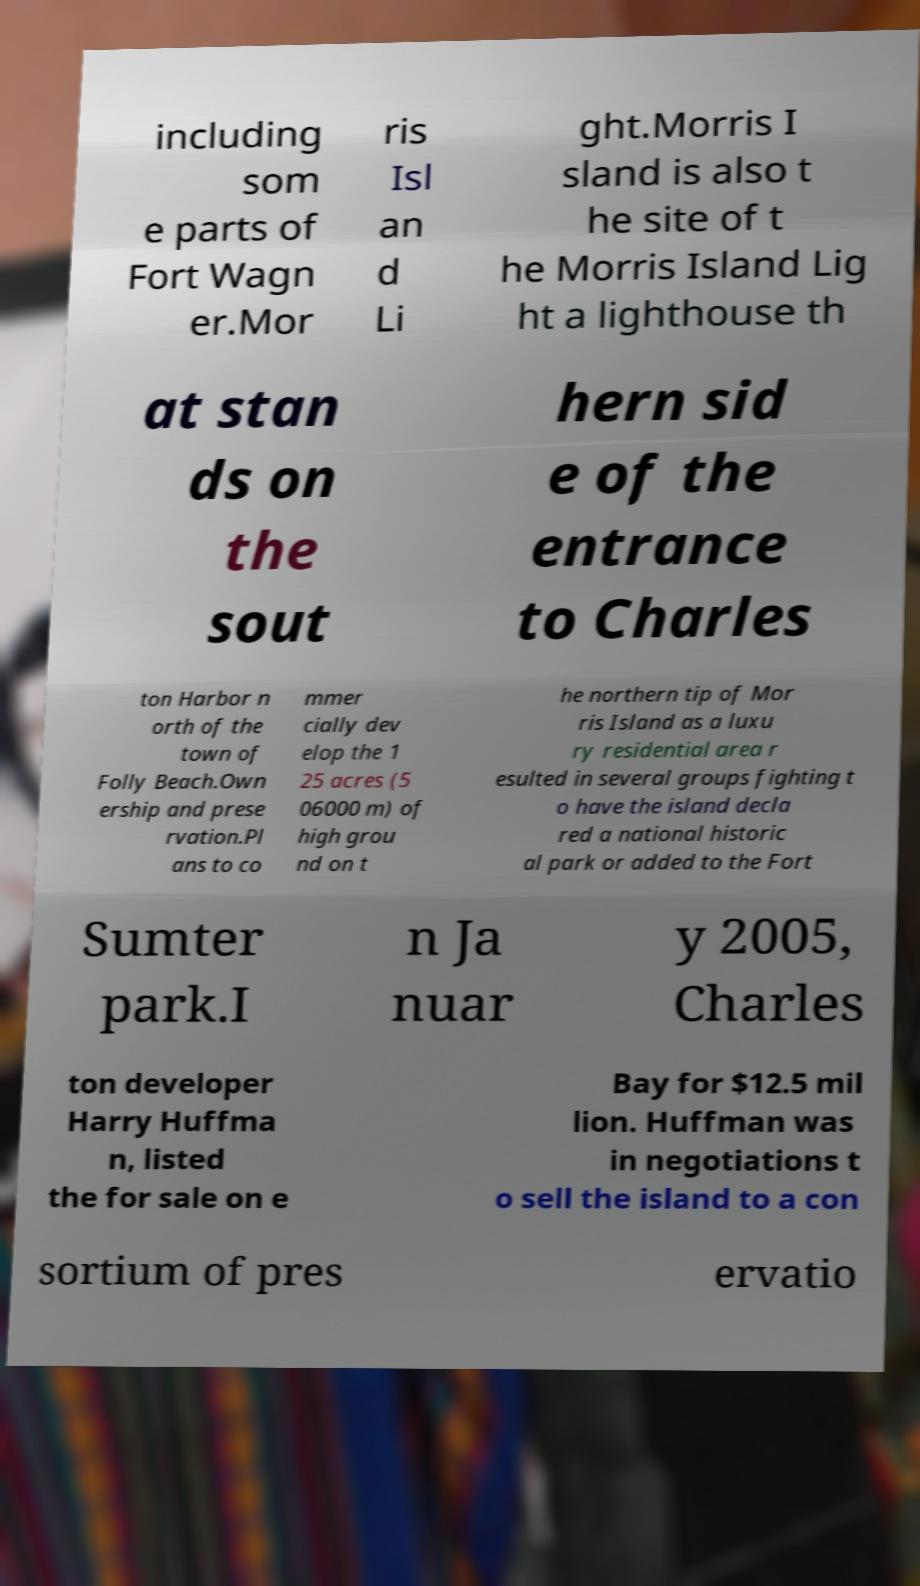Can you accurately transcribe the text from the provided image for me? including som e parts of Fort Wagn er.Mor ris Isl an d Li ght.Morris I sland is also t he site of t he Morris Island Lig ht a lighthouse th at stan ds on the sout hern sid e of the entrance to Charles ton Harbor n orth of the town of Folly Beach.Own ership and prese rvation.Pl ans to co mmer cially dev elop the 1 25 acres (5 06000 m) of high grou nd on t he northern tip of Mor ris Island as a luxu ry residential area r esulted in several groups fighting t o have the island decla red a national historic al park or added to the Fort Sumter park.I n Ja nuar y 2005, Charles ton developer Harry Huffma n, listed the for sale on e Bay for $12.5 mil lion. Huffman was in negotiations t o sell the island to a con sortium of pres ervatio 